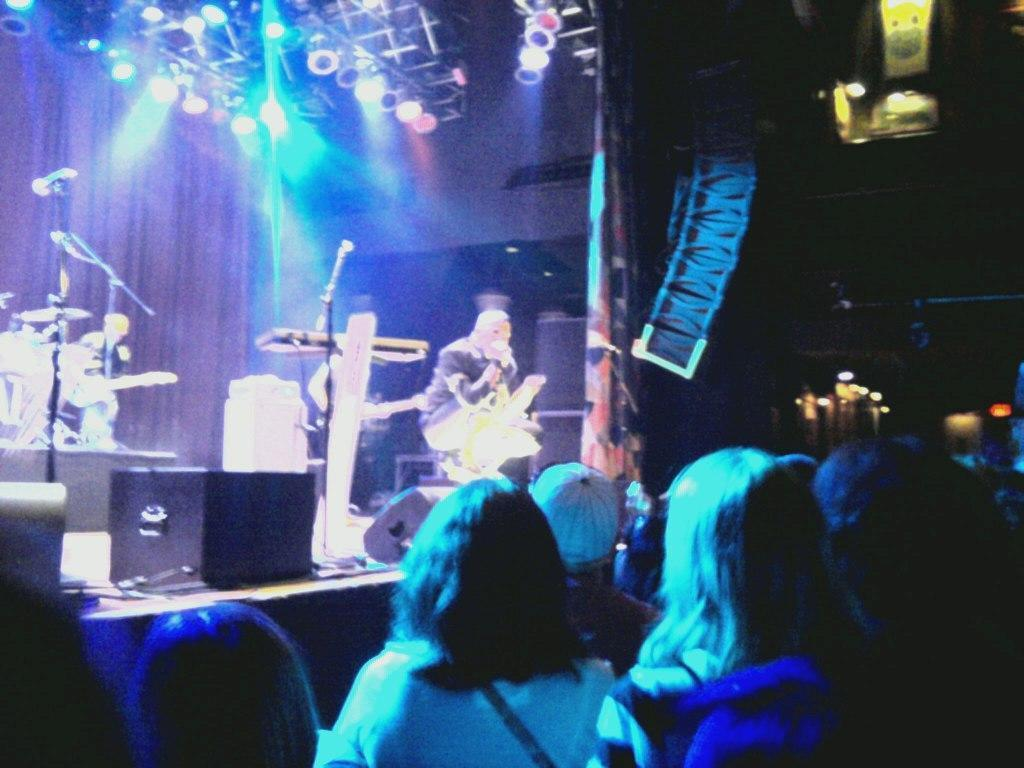What can be seen in the foreground of the image? There are persons in the foreground of the image. What is happening in the background of the image? There is a person on the stage in the background. What equipment is visible on the stage? There are microphones and musical instruments present on the stage. What type of lighting is used on the stage? There is a light on the top of the stage. How is the background of the stage depicted? The background of the stage is dark. Can you hear the goose making noise in the image? There is no goose present in the image, so it is not possible to hear any noise it might make. 